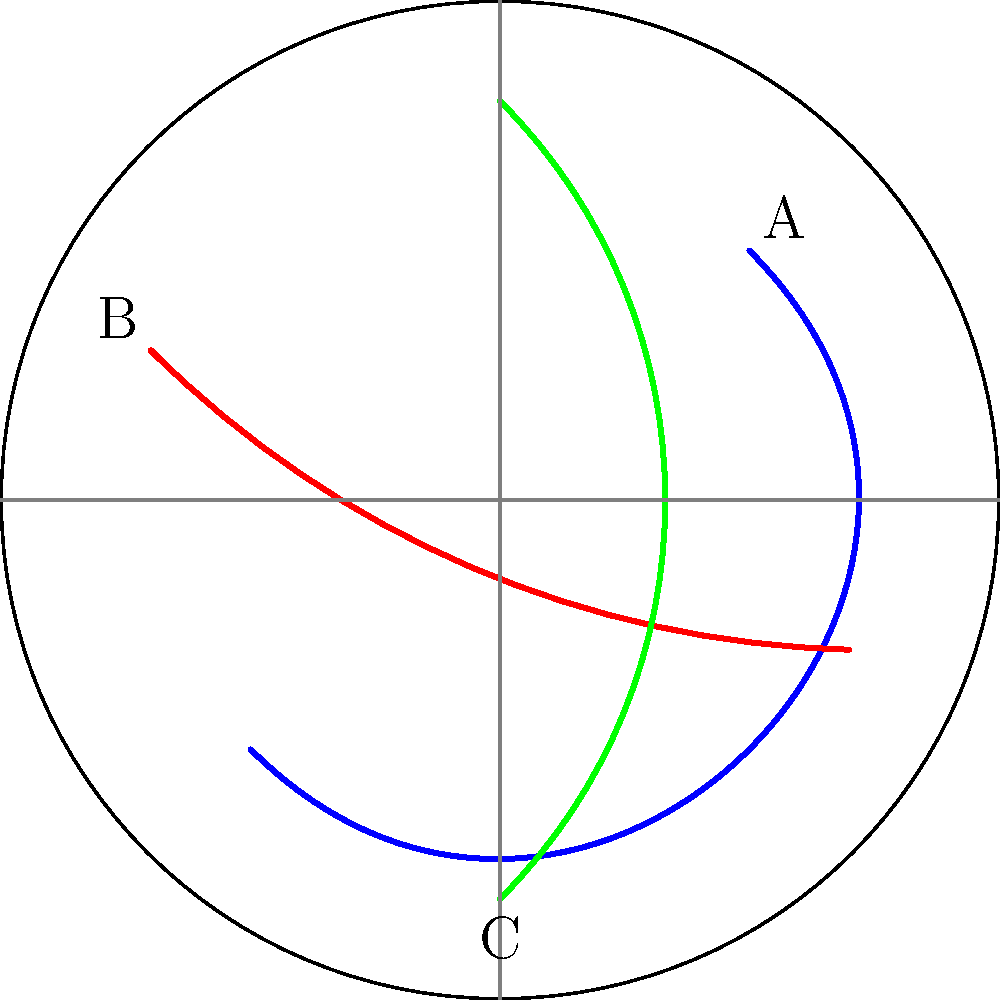Based on the radar image showing bird migration patterns, which pattern is most likely to intersect with your proposed wind farm expansion area if it's located in the northeastern quadrant of the radar coverage? To determine which bird migration pattern is most likely to intersect with the proposed wind farm expansion in the northeastern quadrant, we need to analyze each pattern:

1. Pattern A (blue): 
   - Moves from northeast to southwest
   - Starts in the northeastern quadrant
   - Passes through the center of the radar coverage

2. Pattern B (red):
   - Moves from northwest to southeast
   - Passes through the northern and eastern parts of the radar coverage
   - Does not directly intersect the northeastern quadrant

3. Pattern C (green):
   - Moves from south to north
   - Passes through the center of the radar coverage
   - Extends into the northern part of the radar coverage

Given that the proposed wind farm expansion is in the northeastern quadrant:

- Pattern A starts in this quadrant and would likely intersect with the expansion area.
- Pattern B passes close to but not directly through the northeastern quadrant.
- Pattern C reaches the northern part of the radar coverage but doesn't specifically target the northeastern quadrant.

Therefore, Pattern A (blue) is most likely to intersect with the proposed wind farm expansion area in the northeastern quadrant.
Answer: Pattern A (blue) 